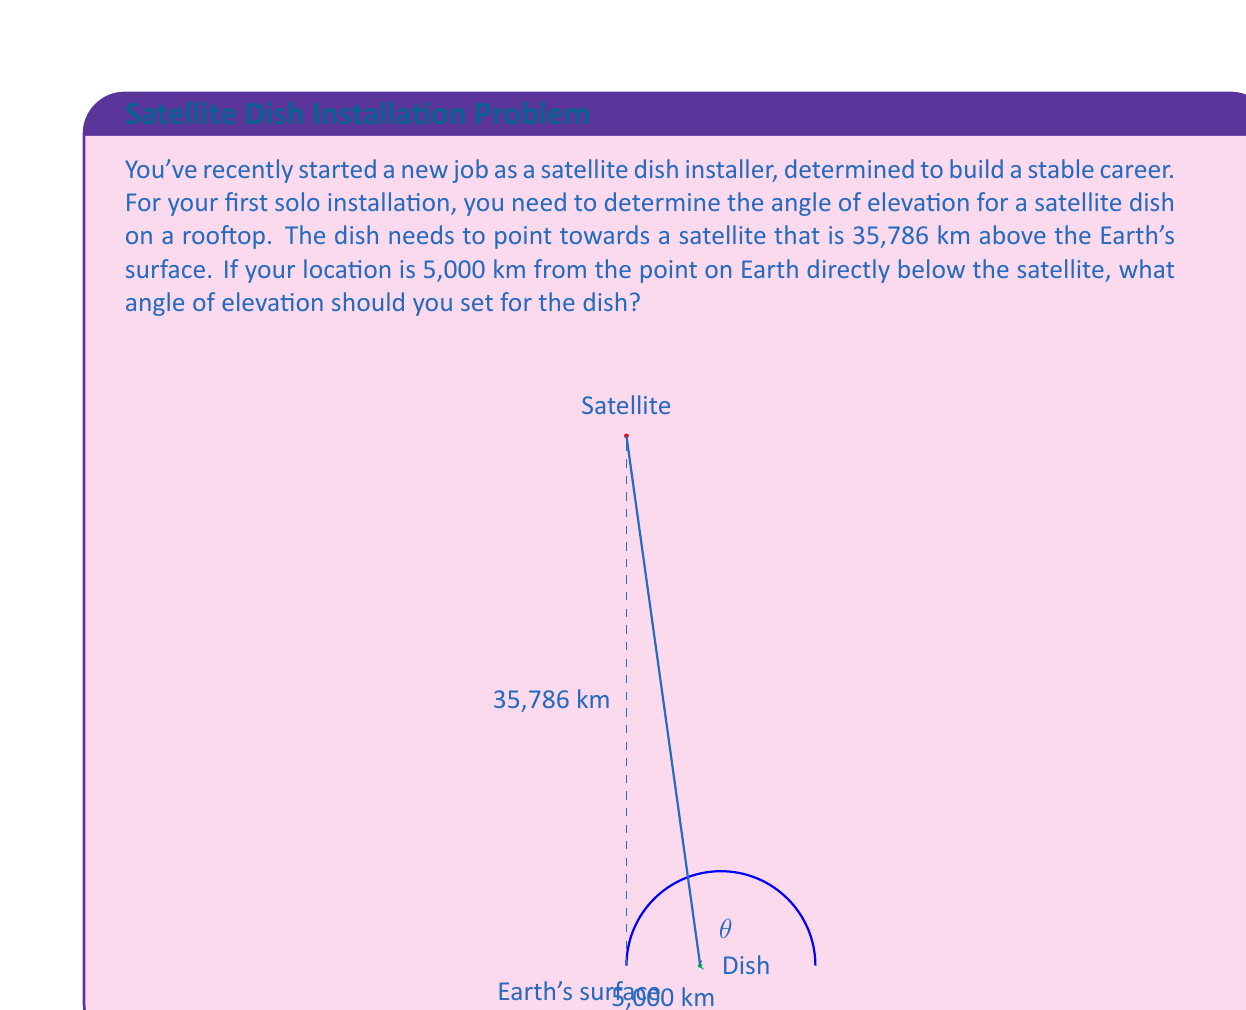Solve this math problem. Let's approach this step-by-step using trigonometry:

1) First, let's visualize the problem. We have a right-angled triangle where:
   - The base is the distance along Earth's surface (5,000 km)
   - The height is the satellite's altitude (35,786 km)
   - The hypotenuse is the line from the dish to the satellite
   - The angle we're looking for is the angle between the base and the hypotenuse

2) We can use the arctangent function to find this angle. The tangent of an angle is the opposite side divided by the adjacent side.

3) In this case:
   - Opposite side = satellite altitude = 35,786 km
   - Adjacent side = distance along Earth's surface = 5,000 km

4) The formula for the angle $\theta$ is:

   $$\theta = \arctan(\frac{\text{opposite}}{\text{adjacent}})$$

5) Plugging in our values:

   $$\theta = \arctan(\frac{35,786}{5,000})$$

6) Using a calculator or computer:

   $$\theta \approx 82.05^\circ$$

7) Therefore, the angle of elevation for the satellite dish should be approximately 82.05°.

Note: This calculation assumes a flat Earth for simplicity. In reality, the curvature of the Earth would slightly affect the calculation, but this approximation is sufficient for most practical purposes.
Answer: $82.05^\circ$ 